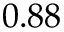Convert formula to latex. <formula><loc_0><loc_0><loc_500><loc_500>0 . 8 8</formula> 